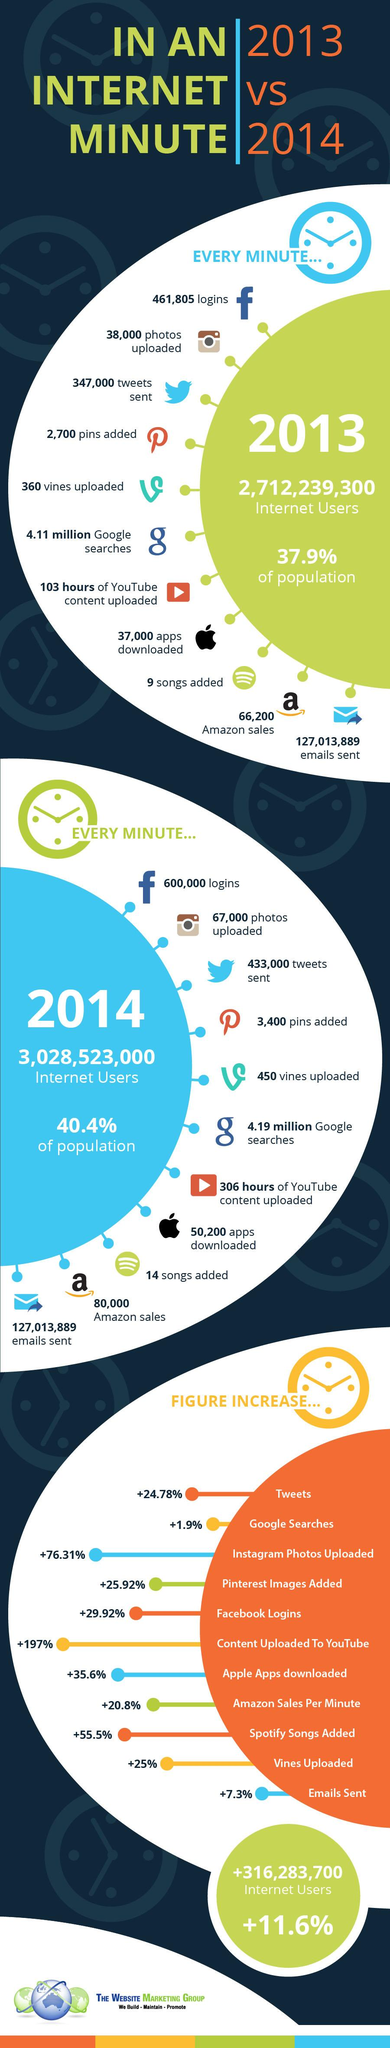Outline some significant characteristics in this image. In the years 2013 and 2014, a total of 409 hours of content was uploaded on YouTube. In the period between 2013 and 2014, the average sales recorded through Amazon were approximately 73,100. The percentage of the population using the internet increased by 2.5% between 2013 and 2014. The number of pins added every single minute increased by 700 between 2013 and 2014. According to the data, Instagram has seen the highest percentage increase in the number of images uploaded compared to other social media platforms. 